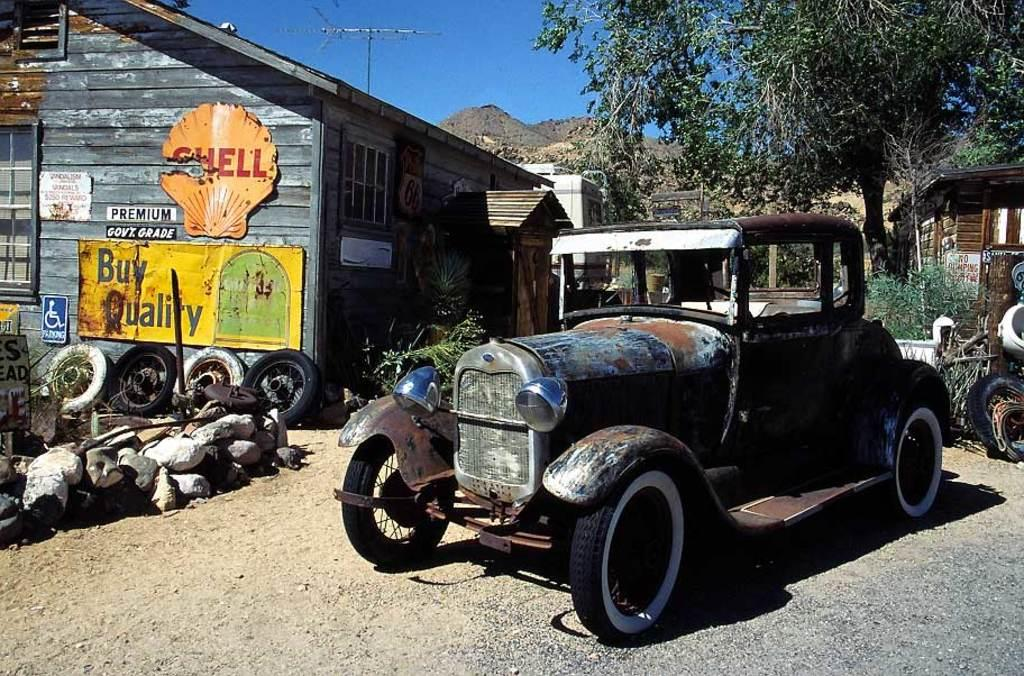What vehicle is present in the image? There is a jeep in the image. Can you describe the condition of the jeep? The jeep is in an old condition. What type of vegetation is on the right side of the image? There are trees on the right side of the image. What type of building is on the left side of the image? There is a wooden house on the left side of the image. How many lizards are sitting on the jeep in the image? There are no lizards present in the image. Who is the guide in the image? There is no guide present in the image. 